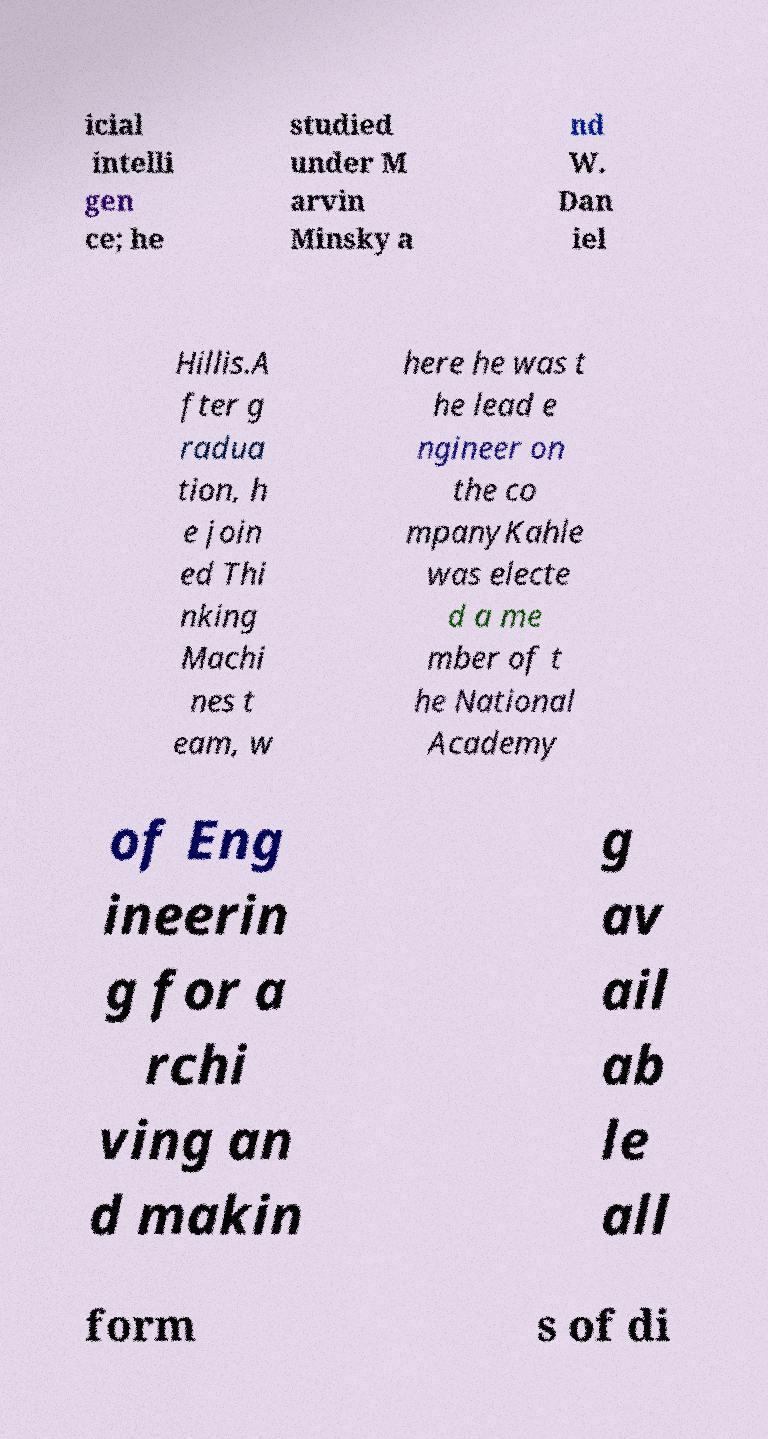Can you accurately transcribe the text from the provided image for me? icial intelli gen ce; he studied under M arvin Minsky a nd W. Dan iel Hillis.A fter g radua tion, h e join ed Thi nking Machi nes t eam, w here he was t he lead e ngineer on the co mpanyKahle was electe d a me mber of t he National Academy of Eng ineerin g for a rchi ving an d makin g av ail ab le all form s of di 